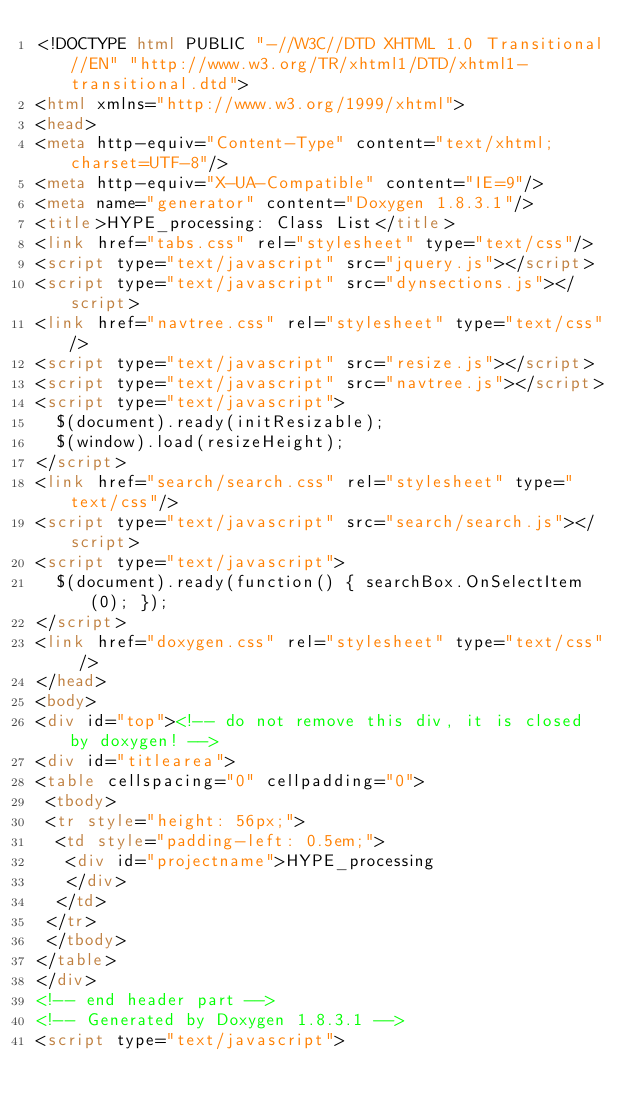Convert code to text. <code><loc_0><loc_0><loc_500><loc_500><_HTML_><!DOCTYPE html PUBLIC "-//W3C//DTD XHTML 1.0 Transitional//EN" "http://www.w3.org/TR/xhtml1/DTD/xhtml1-transitional.dtd">
<html xmlns="http://www.w3.org/1999/xhtml">
<head>
<meta http-equiv="Content-Type" content="text/xhtml;charset=UTF-8"/>
<meta http-equiv="X-UA-Compatible" content="IE=9"/>
<meta name="generator" content="Doxygen 1.8.3.1"/>
<title>HYPE_processing: Class List</title>
<link href="tabs.css" rel="stylesheet" type="text/css"/>
<script type="text/javascript" src="jquery.js"></script>
<script type="text/javascript" src="dynsections.js"></script>
<link href="navtree.css" rel="stylesheet" type="text/css"/>
<script type="text/javascript" src="resize.js"></script>
<script type="text/javascript" src="navtree.js"></script>
<script type="text/javascript">
  $(document).ready(initResizable);
  $(window).load(resizeHeight);
</script>
<link href="search/search.css" rel="stylesheet" type="text/css"/>
<script type="text/javascript" src="search/search.js"></script>
<script type="text/javascript">
  $(document).ready(function() { searchBox.OnSelectItem(0); });
</script>
<link href="doxygen.css" rel="stylesheet" type="text/css" />
</head>
<body>
<div id="top"><!-- do not remove this div, it is closed by doxygen! -->
<div id="titlearea">
<table cellspacing="0" cellpadding="0">
 <tbody>
 <tr style="height: 56px;">
  <td style="padding-left: 0.5em;">
   <div id="projectname">HYPE_processing
   </div>
  </td>
 </tr>
 </tbody>
</table>
</div>
<!-- end header part -->
<!-- Generated by Doxygen 1.8.3.1 -->
<script type="text/javascript"></code> 